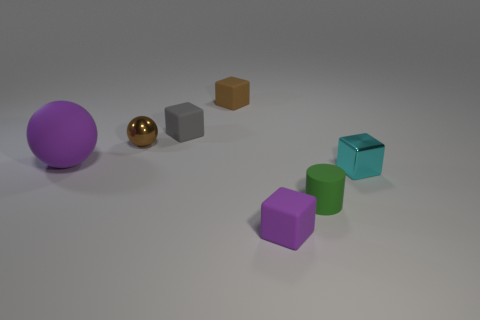Add 3 tiny green cylinders. How many objects exist? 10 Subtract all small cyan metal cubes. How many cubes are left? 3 Subtract all purple blocks. How many blocks are left? 3 Subtract 0 gray balls. How many objects are left? 7 Subtract all blocks. How many objects are left? 3 Subtract 2 spheres. How many spheres are left? 0 Subtract all cyan cubes. Subtract all brown cylinders. How many cubes are left? 3 Subtract all purple matte balls. Subtract all purple blocks. How many objects are left? 5 Add 4 small cyan shiny blocks. How many small cyan shiny blocks are left? 5 Add 5 matte blocks. How many matte blocks exist? 8 